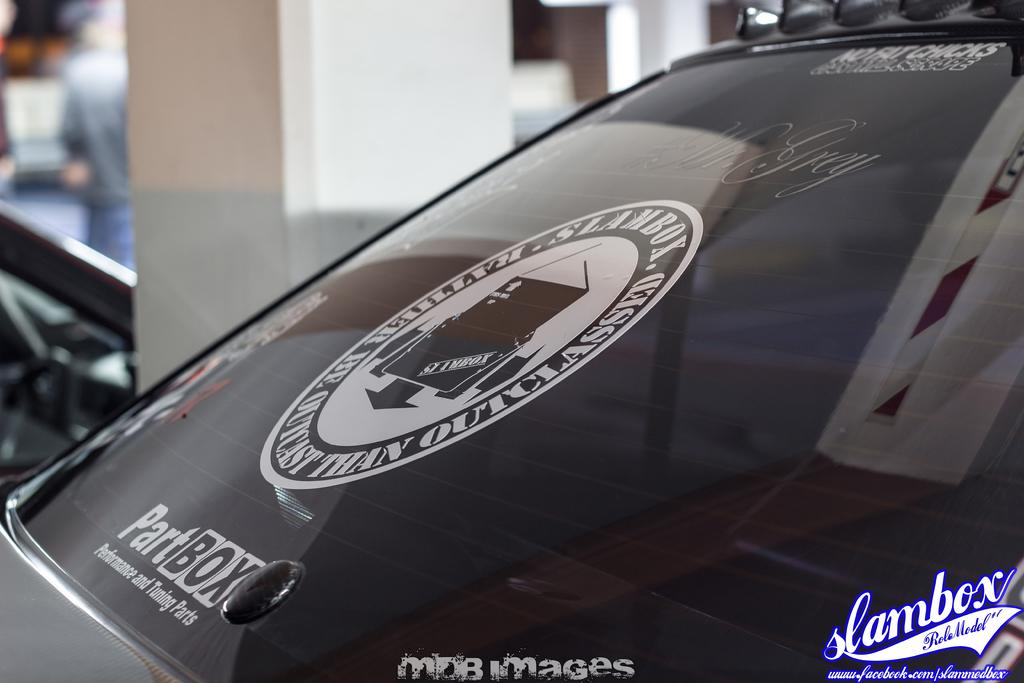What is the main subject of the image? The main subject of the image is a vehicle mirror. What is placed on the vehicle mirror? A log is present on the mirror. What can be seen in the background of the image? There is a pillar and a chair in the background of the image. Is there a person visible in the image? Yes, a person is visible in the background of the image. What type of representative is shown wearing a locket in the image? There is no representative or locket present in the image; it features a vehicle mirror with a log on it and a background with a pillar, a chair, and a person. 